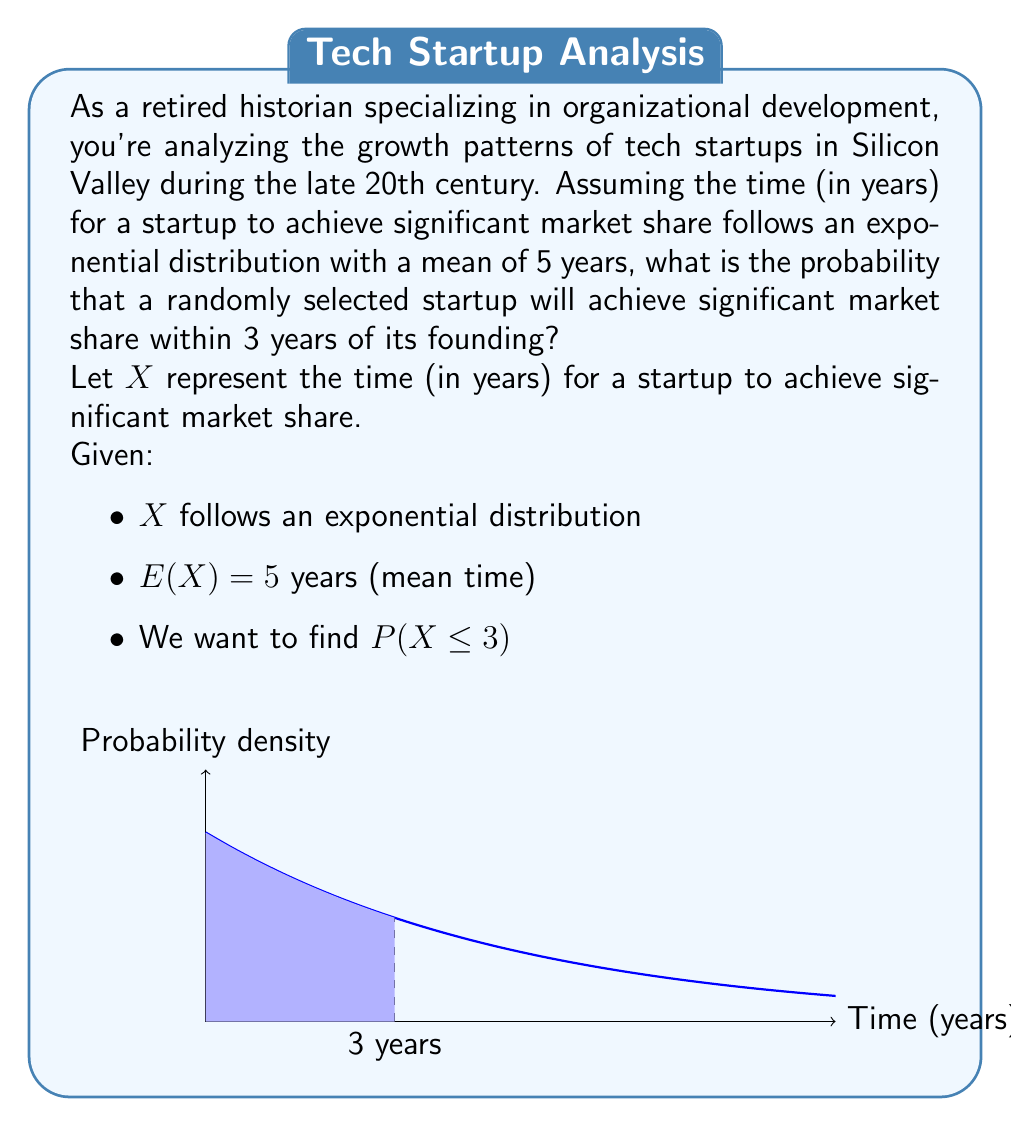Show me your answer to this math problem. Let's approach this step-by-step:

1) For an exponential distribution, the probability density function is given by:

   $f(x) = \lambda e^{-\lambda x}$, where $\lambda$ is the rate parameter.

2) We're given that the mean (expected value) is 5 years. For an exponential distribution, $E(X) = \frac{1}{\lambda}$. Therefore:

   $5 = \frac{1}{\lambda}$
   $\lambda = \frac{1}{5} = 0.2$

3) The cumulative distribution function (CDF) for an exponential distribution is:

   $F(x) = 1 - e^{-\lambda x}$

4) We want to find $P(X \leq 3)$, which is equivalent to $F(3)$:

   $P(X \leq 3) = F(3) = 1 - e^{-\lambda \cdot 3}$

5) Substituting $\lambda = 0.2$ and $x = 3$:

   $P(X \leq 3) = 1 - e^{-0.2 \cdot 3} = 1 - e^{-0.6}$

6) Calculating this value:

   $P(X \leq 3) = 1 - e^{-0.6} \approx 0.4512$

Therefore, the probability that a randomly selected startup will achieve significant market share within 3 years of its founding is approximately 0.4512 or 45.12%.
Answer: $1 - e^{-0.6} \approx 0.4512$ or 45.12% 